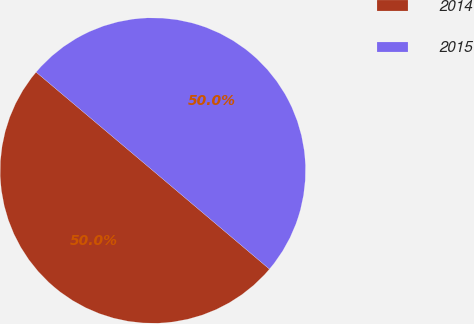<chart> <loc_0><loc_0><loc_500><loc_500><pie_chart><fcel>2014<fcel>2015<nl><fcel>49.98%<fcel>50.02%<nl></chart> 